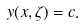<formula> <loc_0><loc_0><loc_500><loc_500>y ( x , \zeta ) = c .</formula> 